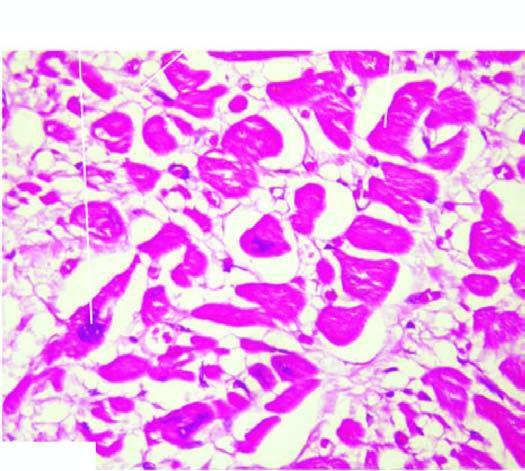what are thick with prominent vesicular nuclei?
Answer the question using a single word or phrase. Individual myocardial fibres 